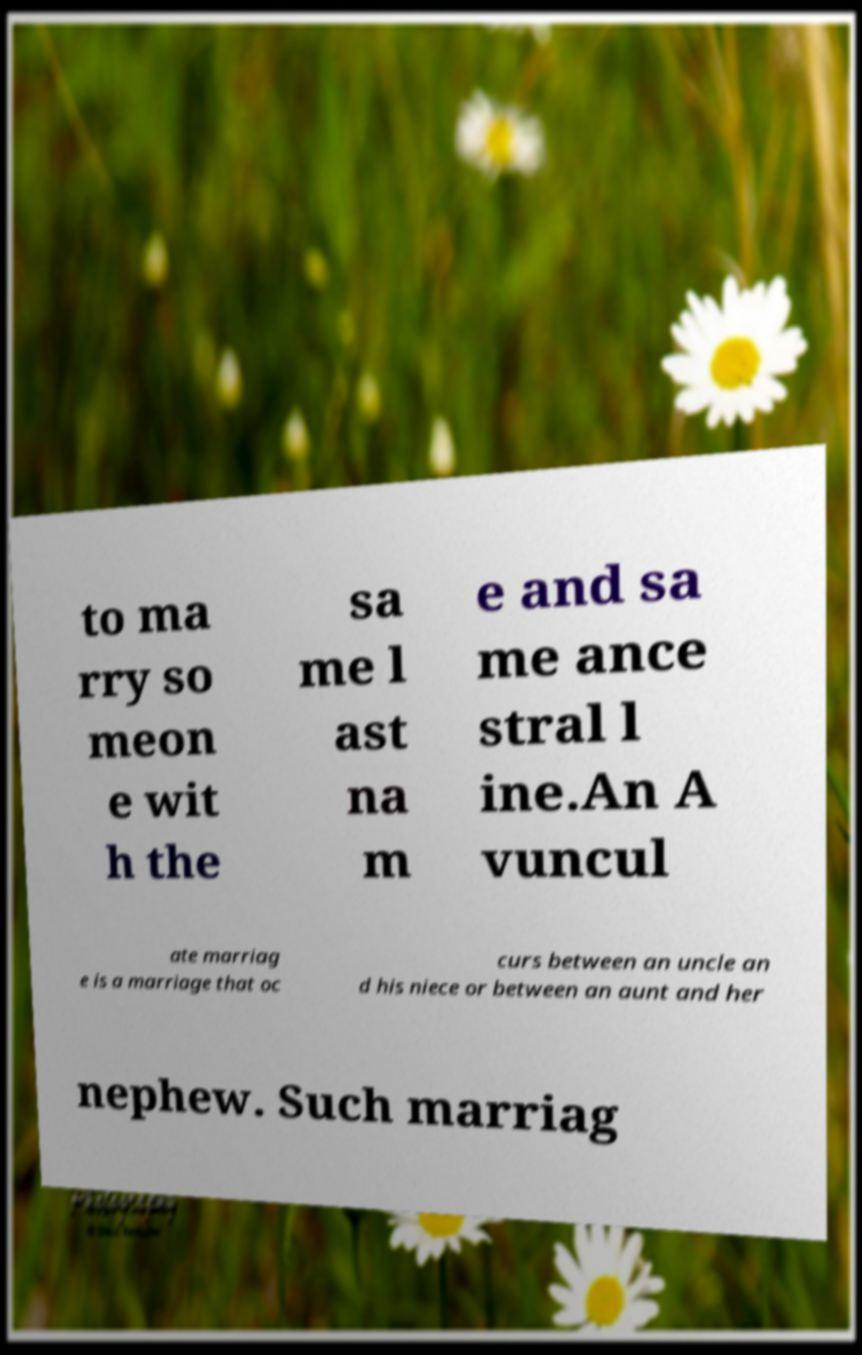There's text embedded in this image that I need extracted. Can you transcribe it verbatim? to ma rry so meon e wit h the sa me l ast na m e and sa me ance stral l ine.An A vuncul ate marriag e is a marriage that oc curs between an uncle an d his niece or between an aunt and her nephew. Such marriag 